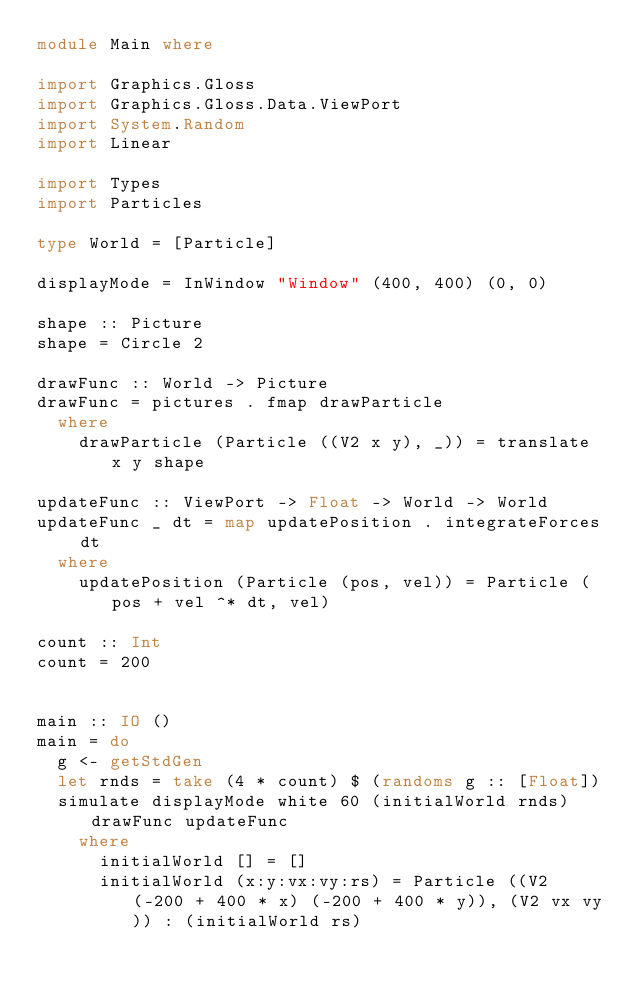Convert code to text. <code><loc_0><loc_0><loc_500><loc_500><_Haskell_>module Main where

import Graphics.Gloss
import Graphics.Gloss.Data.ViewPort
import System.Random
import Linear

import Types
import Particles

type World = [Particle]

displayMode = InWindow "Window" (400, 400) (0, 0)

shape :: Picture
shape = Circle 2

drawFunc :: World -> Picture
drawFunc = pictures . fmap drawParticle
  where
    drawParticle (Particle ((V2 x y), _)) = translate x y shape

updateFunc :: ViewPort -> Float -> World -> World
updateFunc _ dt = map updatePosition . integrateForces dt
  where
    updatePosition (Particle (pos, vel)) = Particle (pos + vel ^* dt, vel)

count :: Int
count = 200


main :: IO ()
main = do
  g <- getStdGen
  let rnds = take (4 * count) $ (randoms g :: [Float])
  simulate displayMode white 60 (initialWorld rnds) drawFunc updateFunc
    where
      initialWorld [] = []
      initialWorld (x:y:vx:vy:rs) = Particle ((V2 (-200 + 400 * x) (-200 + 400 * y)), (V2 vx vy)) : (initialWorld rs)</code> 